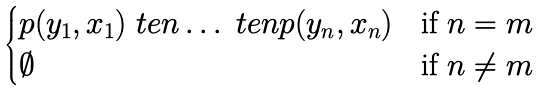<formula> <loc_0><loc_0><loc_500><loc_500>\begin{cases} p ( y _ { 1 } , x _ { 1 } ) \ t e n \dots \ t e n p ( y _ { n } , x _ { n } ) & \text {if } n = m \\ \emptyset & \text {if } n \neq m \end{cases}</formula> 